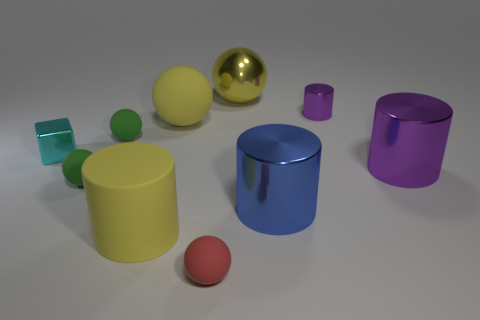Is there a gray matte sphere of the same size as the red rubber ball? After examining the image, there isn't a gray matte sphere present that matches the size of the red rubber ball. The objects in the image vary in color and material, but no such gray sphere is visible. 